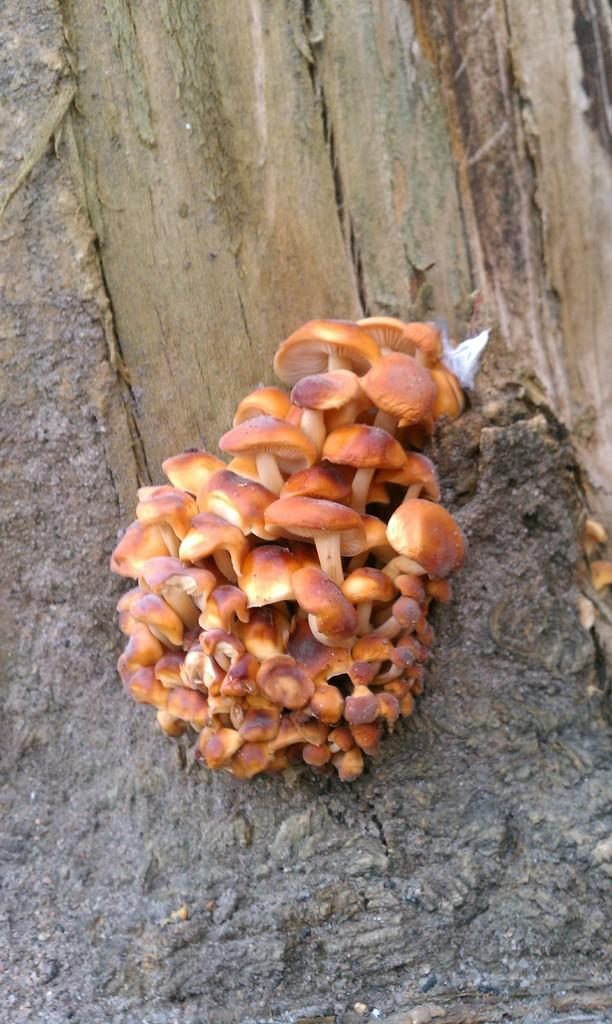What is the main subject in the center of the image? There are mushrooms in the center of the image. Can you describe any other objects or features in the image? There is a wooden object in the background of the image. What type of cracker is the son holding in the image? There is no son or cracker present in the image; it only features mushrooms and a wooden object. 